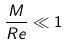Convert formula to latex. <formula><loc_0><loc_0><loc_500><loc_500>\frac { M } { R e } \ll 1</formula> 